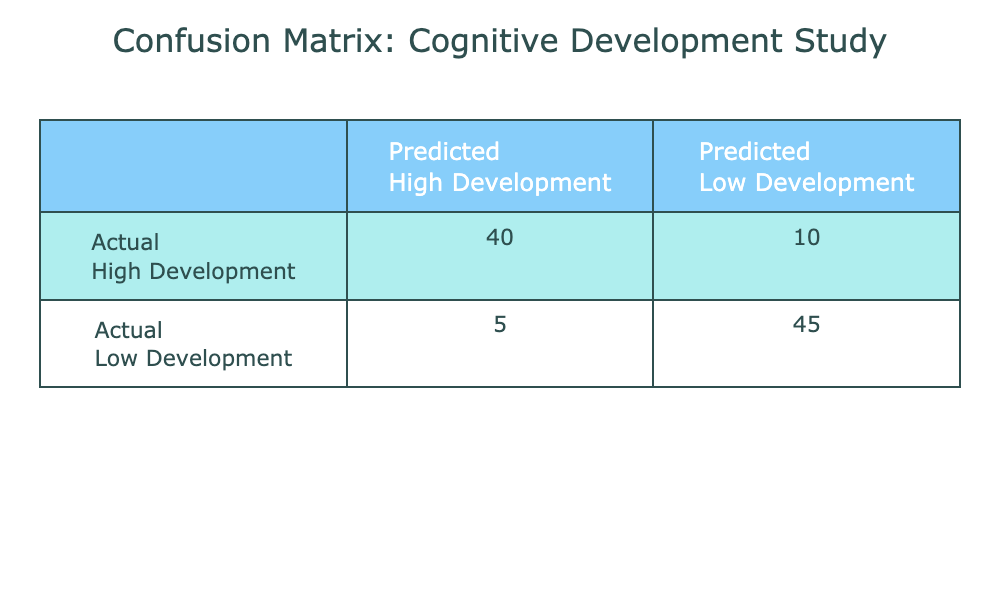What is the count of instances where both the actual and predicted outcomes were classified as "High Development"? According to the table, the intersection of the row labeled "Actual High Development" and the column labeled "Predicted High Development" shows a count of 40.
Answer: 40 What is the total number of instances classified under "Low Development"? The "Low Development" category includes both the "Predicted High Development" (5 instances) and the "Predicted Low Development" (45 instances). Adding these gives 5 + 45 = 50.
Answer: 50 Did the model predict more instances of "High Development" than "Low Development"? The table indicates 45 instances predicted as "Low Development" and 40 predicted as "High Development". Since 45 is more than 40, the statement is true.
Answer: Yes How many instances were incorrectly predicted as "Low Development" when the actual outcome was "High Development"? The data in the table shows that 10 instances were classified as "Low Development" when the actual outcome was "High Development," indicating a misclassification.
Answer: 10 What is the sum of all instances in the "High Development" category? Summing the counts of the "Actual High Development" category gives 40 for predicted as high and 10 for low. So, 40 + 10 = 50.
Answer: 50 What percentage of instances were correctly predicted as "Low Development"? The correct predictions for "Low Development" are those where both actual and predicted are "Low Development", which is 45. The total instances are 40 + 10 + 5 + 45 = 100. The percentage is (45/100) * 100% = 45%.
Answer: 45% How many total instances were predicted as "High Development"? The predicted "High Development" includes 40 from actual high and 5 from actual low. Adding these together gives us 40 + 5 = 45 instances predicted as "High Development".
Answer: 45 What is the difference in count between correctly predicted "High Development" and "Low Development"? The correctly predicted count for "High Development" is 40, while for "Low Development," it is 45. The difference is 45 - 40 = 5, meaning there are 5 more correctly predicted low development instances than high.
Answer: 5 How many samples had actual "Low Development" with a predicted outcome of "High Development"? The table shows that there are 5 instances where the actual outcome is "Low Development" but the predicted outcome is "High Development."
Answer: 5 